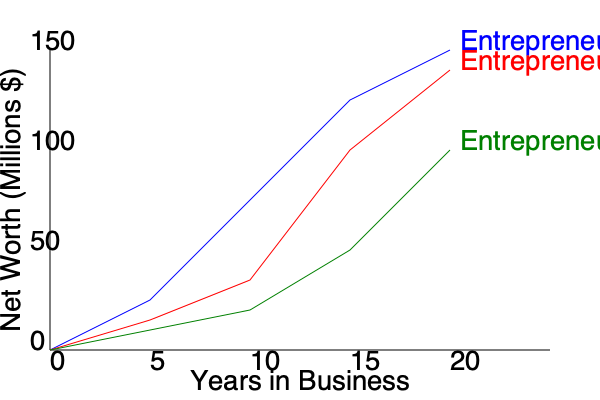Based on the line graph comparing the career trajectories of three entrepreneurs, which entrepreneur showed the most consistent growth in net worth over the 20-year period? To determine which entrepreneur showed the most consistent growth, we need to analyze the slope and shape of each line:

1. Entrepreneur A (blue line):
   - Starts with rapid growth
   - Slope decreases over time, indicating slowing growth
   - Ends with the highest net worth but shows inconsistent growth rate

2. Entrepreneur B (red line):
   - Starts with moderate growth
   - Experiences a significant increase in growth rate between years 10-15
   - Shows inconsistent growth pattern

3. Entrepreneur C (green line):
   - Starts with the slowest growth
   - Maintains a relatively steady slope throughout the 20-year period
   - While ending with the lowest net worth, the growth rate remains the most consistent

Consistency in growth is characterized by a steady increase over time, represented by a relatively straight line with a constant slope. Among the three entrepreneurs, Entrepreneur C's line most closely resembles this pattern, showing the most consistent growth despite not achieving the highest overall net worth.
Answer: Entrepreneur C 